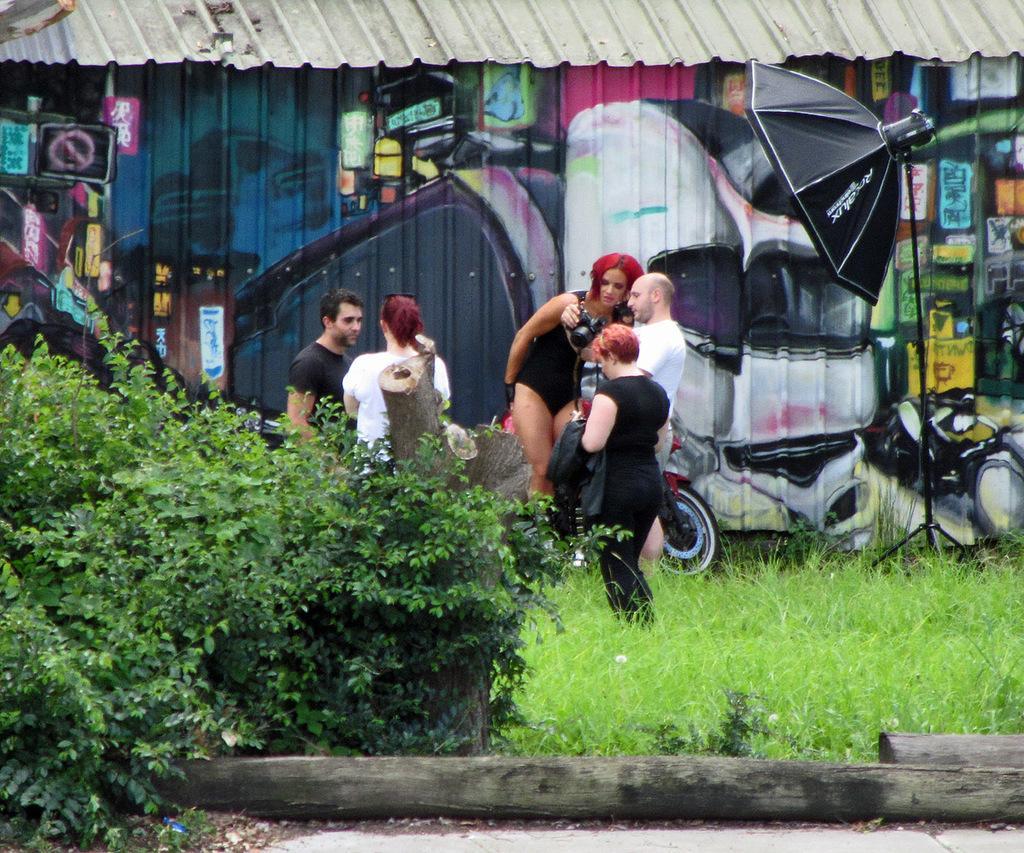How would you summarize this image in a sentence or two? In this image there are a few people standing on the ground. There is grass on the ground. To the right there is a tripod stand. Behind them there is a wall of a house. There is the graffiti painting on the wall. To the left there are plants. At the bottom there are logs of wood. 